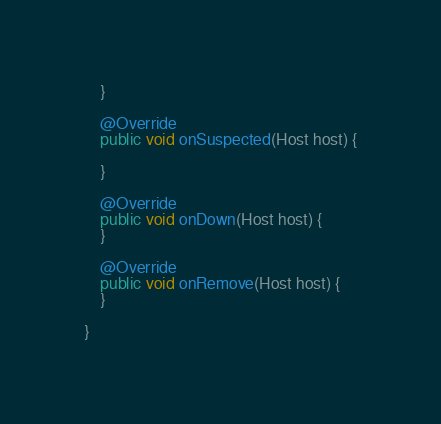Convert code to text. <code><loc_0><loc_0><loc_500><loc_500><_Java_>    }

    @Override
    public void onSuspected(Host host) {

    }

    @Override
    public void onDown(Host host) {
    }

    @Override
    public void onRemove(Host host) {
    }

}</code> 